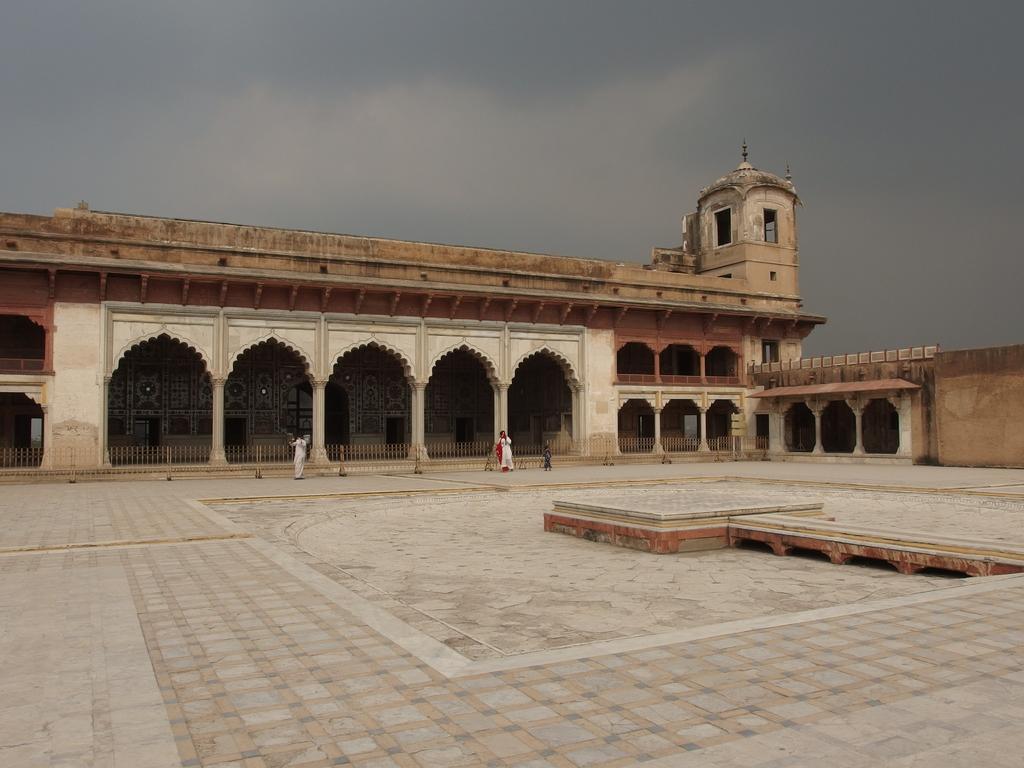Could you give a brief overview of what you see in this image? In this image, I can see a Lahore fort. There are two persons standing. In the background, there is the sky. 